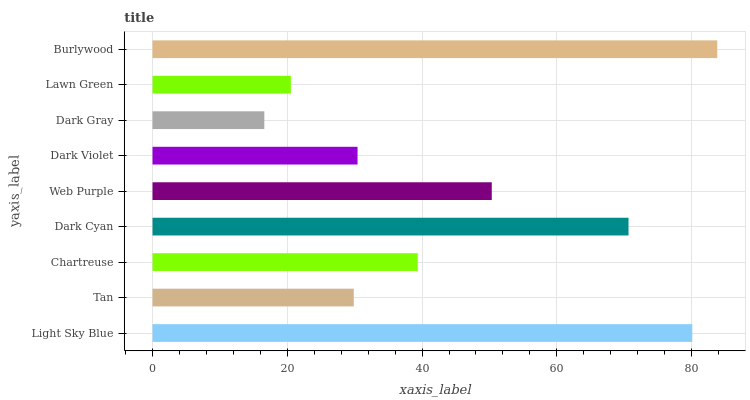Is Dark Gray the minimum?
Answer yes or no. Yes. Is Burlywood the maximum?
Answer yes or no. Yes. Is Tan the minimum?
Answer yes or no. No. Is Tan the maximum?
Answer yes or no. No. Is Light Sky Blue greater than Tan?
Answer yes or no. Yes. Is Tan less than Light Sky Blue?
Answer yes or no. Yes. Is Tan greater than Light Sky Blue?
Answer yes or no. No. Is Light Sky Blue less than Tan?
Answer yes or no. No. Is Chartreuse the high median?
Answer yes or no. Yes. Is Chartreuse the low median?
Answer yes or no. Yes. Is Tan the high median?
Answer yes or no. No. Is Burlywood the low median?
Answer yes or no. No. 